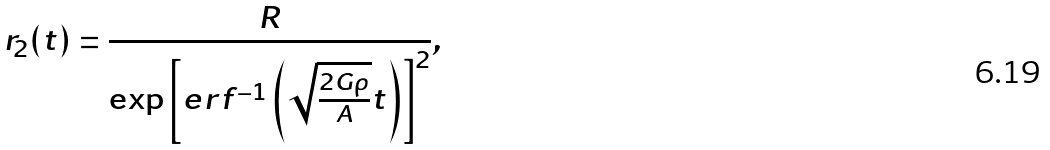<formula> <loc_0><loc_0><loc_500><loc_500>r _ { 2 } ( t ) = \frac { R } { \exp { \left [ e r f ^ { - 1 } \left ( \sqrt { \frac { 2 G \rho } { A } } t \right ) \right ] ^ { 2 } } } ,</formula> 